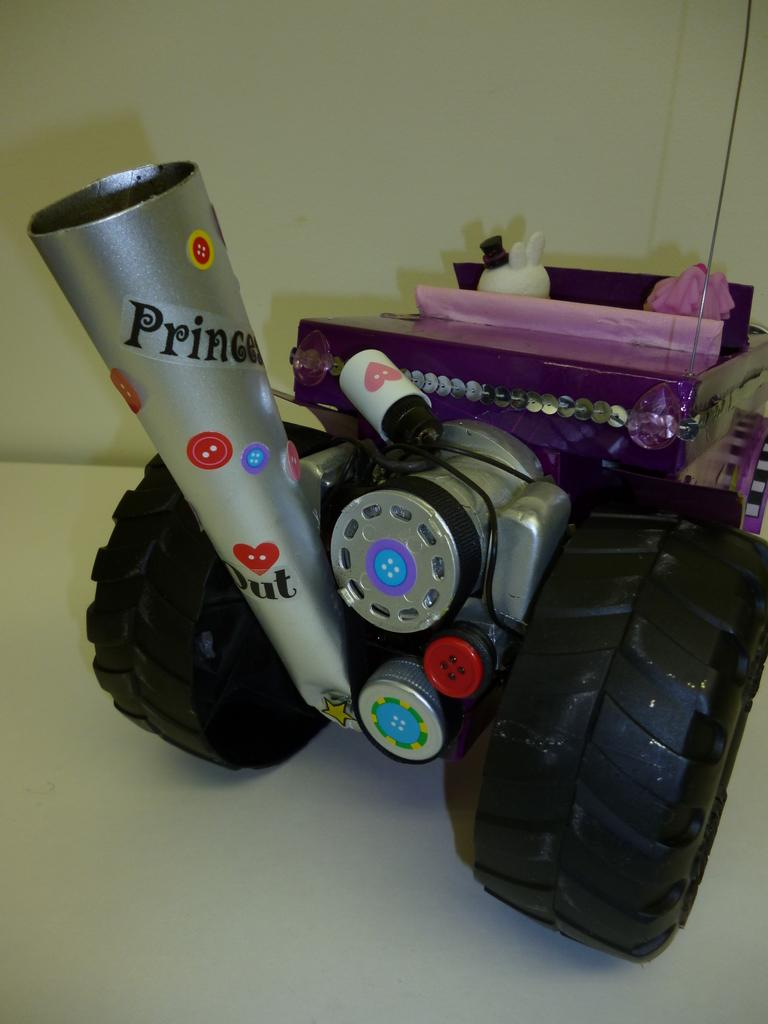What is the main object in the image? There is a toy in the image. Are there any other objects present in the image? Yes, there are other objects in the image. What is the color of the surface on which the objects are placed? The objects are on a white surface. What type of chalk is being used to draw on the stage in the image? There is no chalk or stage present in the image; it only features a toy and other objects on a white surface. 